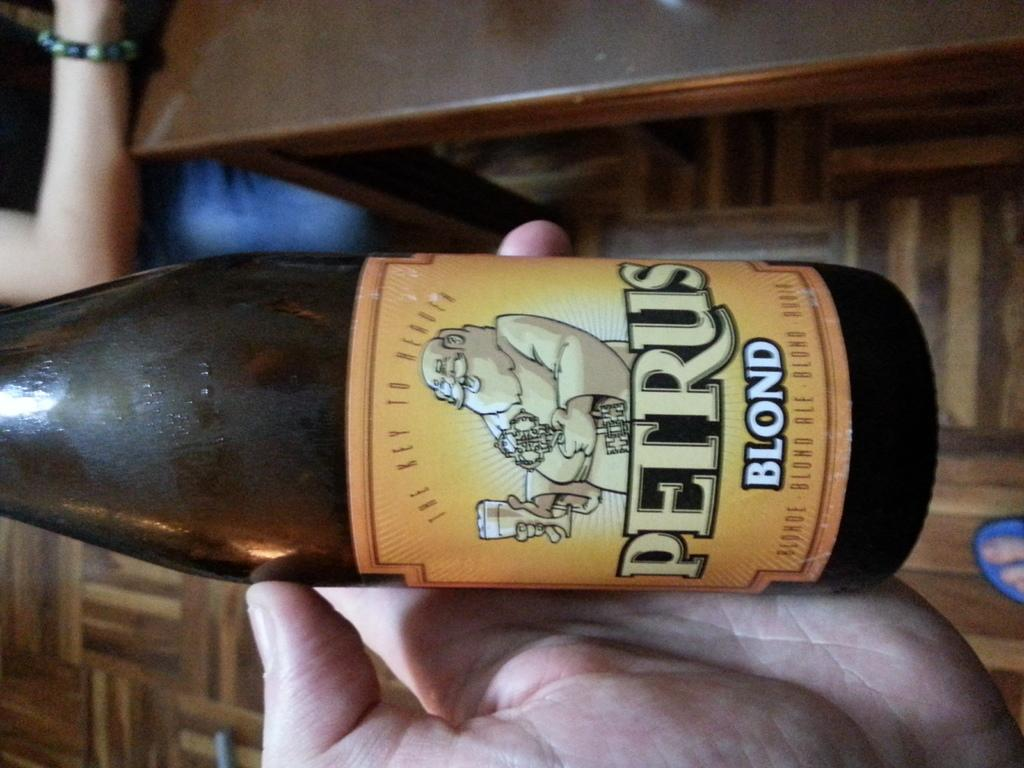<image>
Summarize the visual content of the image. the words perus blond that is on a bottle 